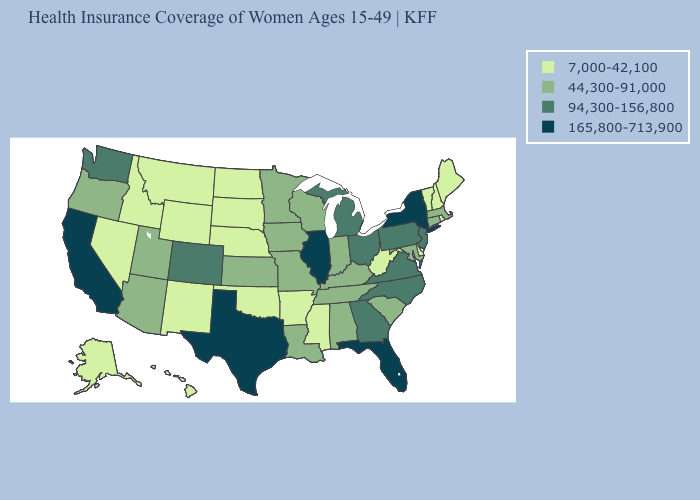Which states have the lowest value in the USA?
Short answer required. Alaska, Arkansas, Delaware, Hawaii, Idaho, Maine, Mississippi, Montana, Nebraska, Nevada, New Hampshire, New Mexico, North Dakota, Oklahoma, Rhode Island, South Dakota, Vermont, West Virginia, Wyoming. Does Florida have the highest value in the USA?
Concise answer only. Yes. Name the states that have a value in the range 44,300-91,000?
Quick response, please. Alabama, Arizona, Connecticut, Indiana, Iowa, Kansas, Kentucky, Louisiana, Maryland, Massachusetts, Minnesota, Missouri, Oregon, South Carolina, Tennessee, Utah, Wisconsin. What is the highest value in the USA?
Quick response, please. 165,800-713,900. What is the lowest value in the USA?
Give a very brief answer. 7,000-42,100. Does Arkansas have a lower value than California?
Give a very brief answer. Yes. Among the states that border South Dakota , which have the highest value?
Short answer required. Iowa, Minnesota. Does Minnesota have the highest value in the MidWest?
Be succinct. No. What is the value of Texas?
Short answer required. 165,800-713,900. Which states hav the highest value in the West?
Write a very short answer. California. What is the highest value in the MidWest ?
Be succinct. 165,800-713,900. What is the lowest value in states that border Iowa?
Keep it brief. 7,000-42,100. Does Delaware have the highest value in the South?
Be succinct. No. Does the map have missing data?
Write a very short answer. No. Does Arizona have the lowest value in the West?
Quick response, please. No. 